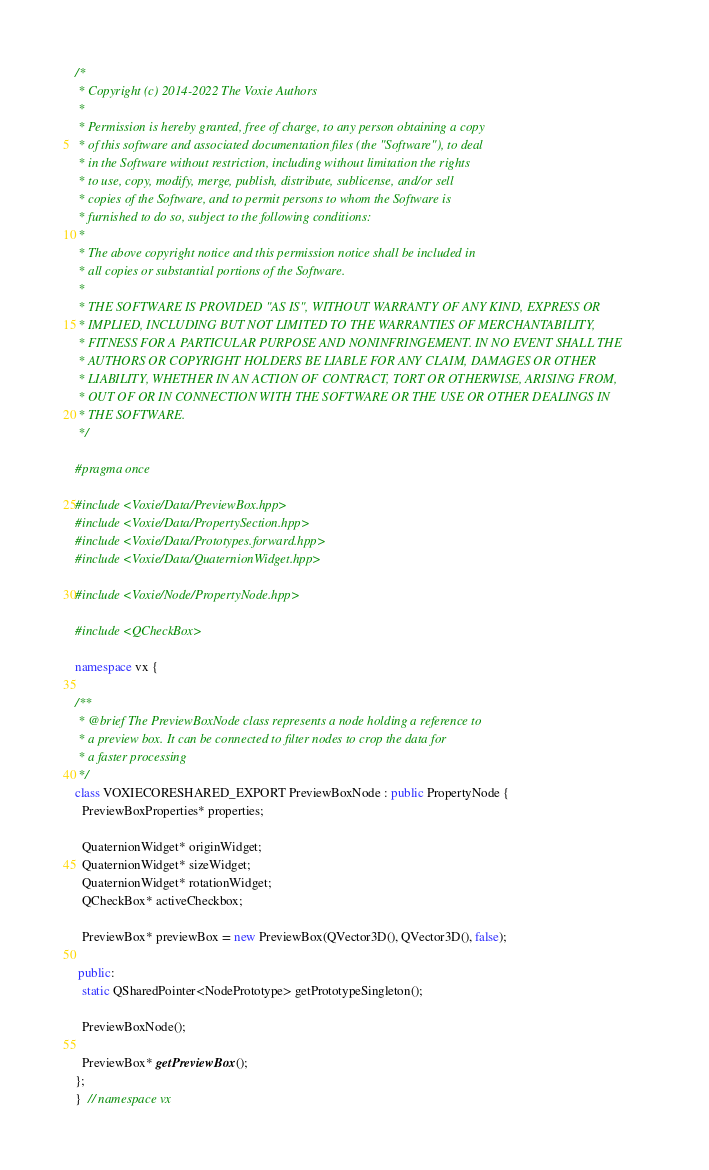Convert code to text. <code><loc_0><loc_0><loc_500><loc_500><_C++_>/*
 * Copyright (c) 2014-2022 The Voxie Authors
 *
 * Permission is hereby granted, free of charge, to any person obtaining a copy
 * of this software and associated documentation files (the "Software"), to deal
 * in the Software without restriction, including without limitation the rights
 * to use, copy, modify, merge, publish, distribute, sublicense, and/or sell
 * copies of the Software, and to permit persons to whom the Software is
 * furnished to do so, subject to the following conditions:
 *
 * The above copyright notice and this permission notice shall be included in
 * all copies or substantial portions of the Software.
 *
 * THE SOFTWARE IS PROVIDED "AS IS", WITHOUT WARRANTY OF ANY KIND, EXPRESS OR
 * IMPLIED, INCLUDING BUT NOT LIMITED TO THE WARRANTIES OF MERCHANTABILITY,
 * FITNESS FOR A PARTICULAR PURPOSE AND NONINFRINGEMENT. IN NO EVENT SHALL THE
 * AUTHORS OR COPYRIGHT HOLDERS BE LIABLE FOR ANY CLAIM, DAMAGES OR OTHER
 * LIABILITY, WHETHER IN AN ACTION OF CONTRACT, TORT OR OTHERWISE, ARISING FROM,
 * OUT OF OR IN CONNECTION WITH THE SOFTWARE OR THE USE OR OTHER DEALINGS IN
 * THE SOFTWARE.
 */

#pragma once

#include <Voxie/Data/PreviewBox.hpp>
#include <Voxie/Data/PropertySection.hpp>
#include <Voxie/Data/Prototypes.forward.hpp>
#include <Voxie/Data/QuaternionWidget.hpp>

#include <Voxie/Node/PropertyNode.hpp>

#include <QCheckBox>

namespace vx {

/**
 * @brief The PreviewBoxNode class represents a node holding a reference to
 * a preview box. It can be connected to filter nodes to crop the data for
 * a faster processing
 */
class VOXIECORESHARED_EXPORT PreviewBoxNode : public PropertyNode {
  PreviewBoxProperties* properties;

  QuaternionWidget* originWidget;
  QuaternionWidget* sizeWidget;
  QuaternionWidget* rotationWidget;
  QCheckBox* activeCheckbox;

  PreviewBox* previewBox = new PreviewBox(QVector3D(), QVector3D(), false);

 public:
  static QSharedPointer<NodePrototype> getPrototypeSingleton();

  PreviewBoxNode();

  PreviewBox* getPreviewBox();
};
}  // namespace vx
</code> 